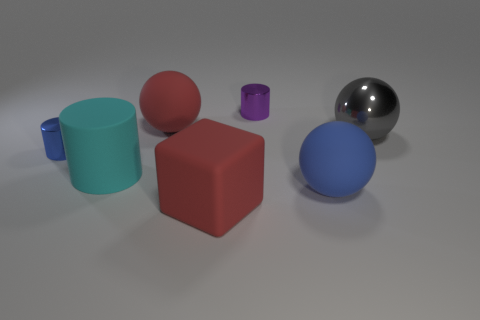What size is the gray shiny ball?
Your answer should be very brief. Large. Does the rubber object behind the tiny blue thing have the same color as the matte object left of the large red sphere?
Your answer should be compact. No. What number of other things are the same material as the gray thing?
Your response must be concise. 2. Are there any blue rubber objects?
Offer a terse response. Yes. Are the large red object that is in front of the tiny blue metallic thing and the big gray object made of the same material?
Your answer should be very brief. No. There is a small blue thing that is the same shape as the large cyan thing; what is it made of?
Provide a short and direct response. Metal. There is a ball that is the same color as the rubber block; what is its material?
Give a very brief answer. Rubber. Is the number of big purple balls less than the number of rubber spheres?
Provide a short and direct response. Yes. There is a matte object that is behind the blue metal object; does it have the same color as the large rubber block?
Ensure brevity in your answer.  Yes. The cylinder that is made of the same material as the cube is what color?
Your answer should be compact. Cyan. 